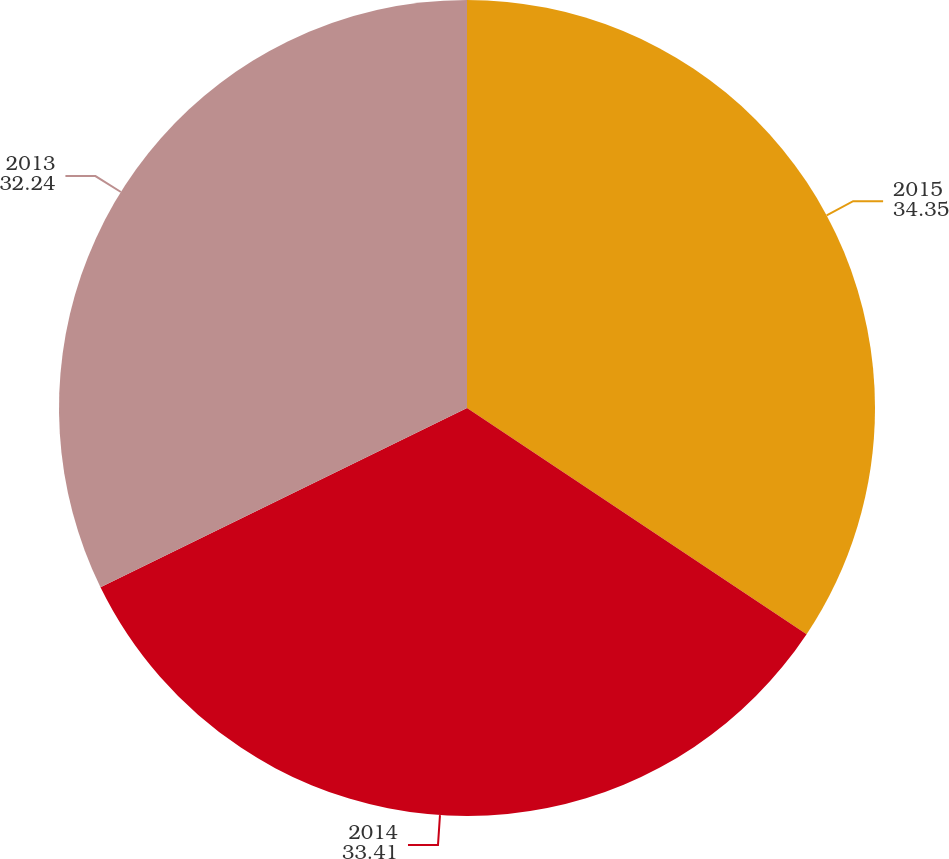Convert chart. <chart><loc_0><loc_0><loc_500><loc_500><pie_chart><fcel>2015<fcel>2014<fcel>2013<nl><fcel>34.35%<fcel>33.41%<fcel>32.24%<nl></chart> 